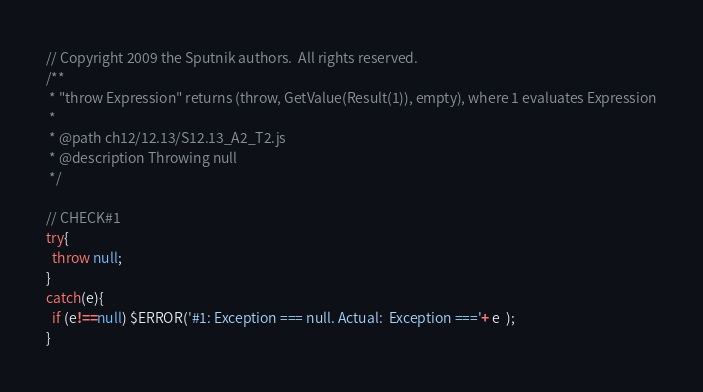<code> <loc_0><loc_0><loc_500><loc_500><_JavaScript_>// Copyright 2009 the Sputnik authors.  All rights reserved.
/**
 * "throw Expression" returns (throw, GetValue(Result(1)), empty), where 1 evaluates Expression
 *
 * @path ch12/12.13/S12.13_A2_T2.js
 * @description Throwing null
 */

// CHECK#1
try{
  throw null;
}
catch(e){
  if (e!==null) $ERROR('#1: Exception === null. Actual:  Exception ==='+ e  );
}

</code> 